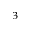Convert formula to latex. <formula><loc_0><loc_0><loc_500><loc_500>^ { 3 }</formula> 